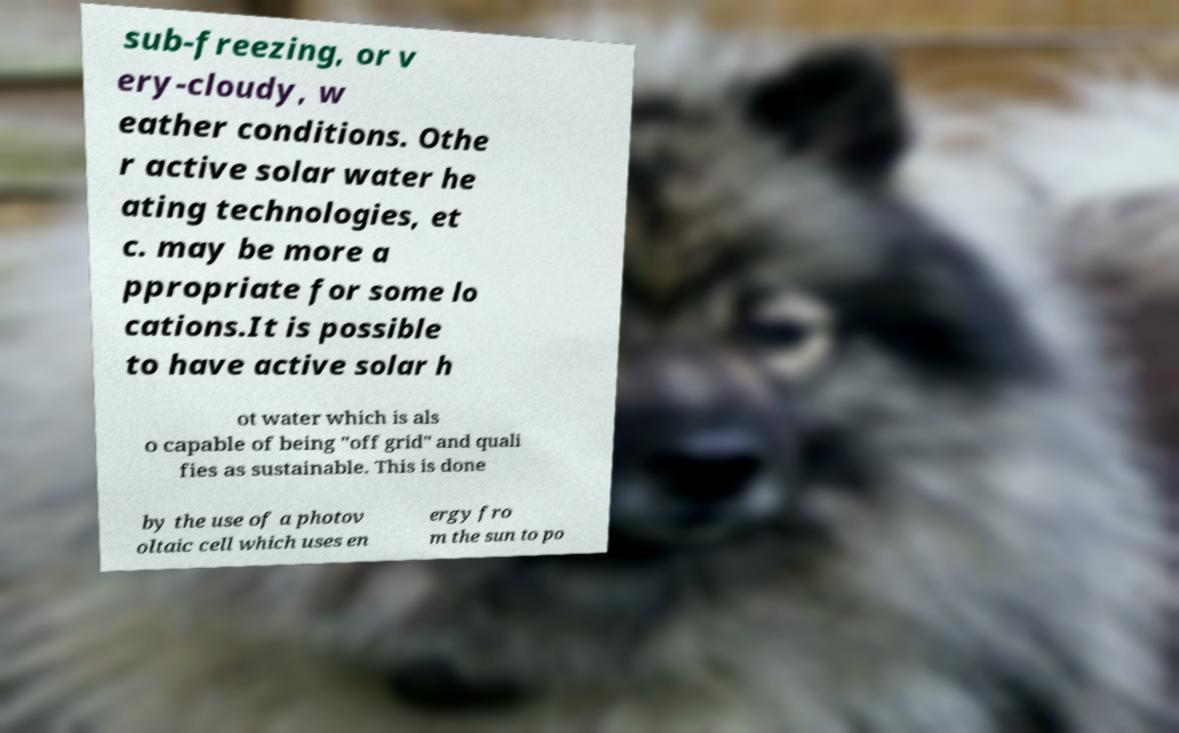Can you read and provide the text displayed in the image?This photo seems to have some interesting text. Can you extract and type it out for me? sub-freezing, or v ery-cloudy, w eather conditions. Othe r active solar water he ating technologies, et c. may be more a ppropriate for some lo cations.It is possible to have active solar h ot water which is als o capable of being "off grid" and quali fies as sustainable. This is done by the use of a photov oltaic cell which uses en ergy fro m the sun to po 